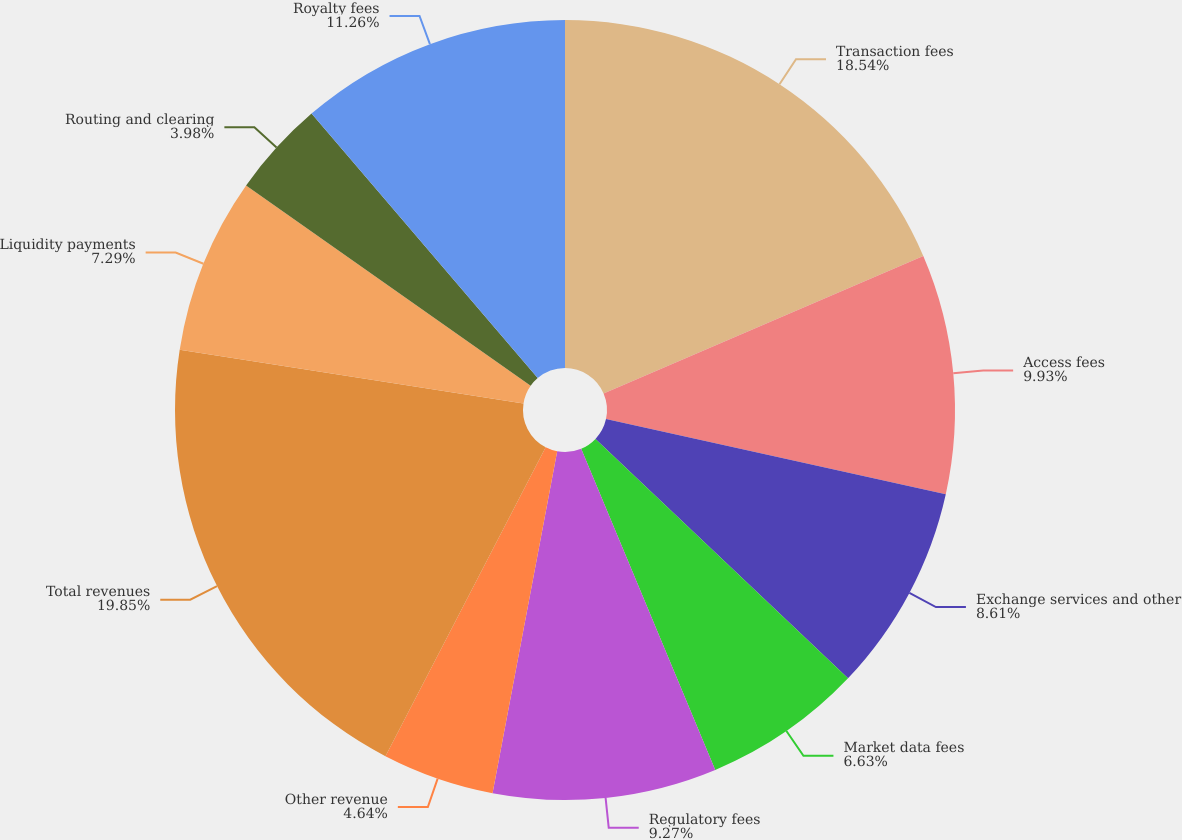Convert chart to OTSL. <chart><loc_0><loc_0><loc_500><loc_500><pie_chart><fcel>Transaction fees<fcel>Access fees<fcel>Exchange services and other<fcel>Market data fees<fcel>Regulatory fees<fcel>Other revenue<fcel>Total revenues<fcel>Liquidity payments<fcel>Routing and clearing<fcel>Royalty fees<nl><fcel>18.54%<fcel>9.93%<fcel>8.61%<fcel>6.63%<fcel>9.27%<fcel>4.64%<fcel>19.86%<fcel>7.29%<fcel>3.98%<fcel>11.26%<nl></chart> 